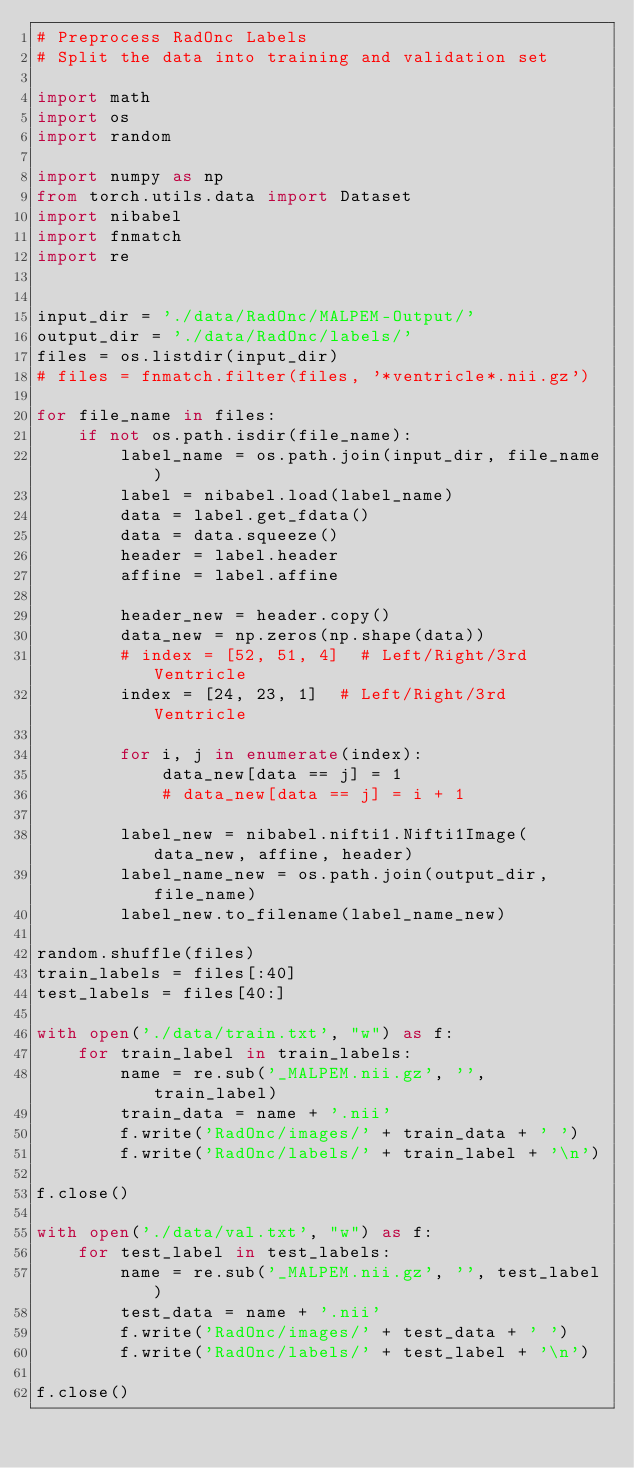<code> <loc_0><loc_0><loc_500><loc_500><_Python_># Preprocess RadOnc Labels
# Split the data into training and validation set

import math
import os
import random

import numpy as np
from torch.utils.data import Dataset
import nibabel
import fnmatch
import re


input_dir = './data/RadOnc/MALPEM-Output/'
output_dir = './data/RadOnc/labels/'
files = os.listdir(input_dir)
# files = fnmatch.filter(files, '*ventricle*.nii.gz')

for file_name in files:
    if not os.path.isdir(file_name):
        label_name = os.path.join(input_dir, file_name)
        label = nibabel.load(label_name)
        data = label.get_fdata()
        data = data.squeeze()
        header = label.header
        affine = label.affine

        header_new = header.copy()
        data_new = np.zeros(np.shape(data))
        # index = [52, 51, 4]  # Left/Right/3rd Ventricle
        index = [24, 23, 1]  # Left/Right/3rd Ventricle

        for i, j in enumerate(index):
            data_new[data == j] = 1
            # data_new[data == j] = i + 1

        label_new = nibabel.nifti1.Nifti1Image(data_new, affine, header)
        label_name_new = os.path.join(output_dir, file_name)
        label_new.to_filename(label_name_new)

random.shuffle(files)
train_labels = files[:40]
test_labels = files[40:]

with open('./data/train.txt', "w") as f:
    for train_label in train_labels:
        name = re.sub('_MALPEM.nii.gz', '', train_label)
        train_data = name + '.nii'
        f.write('RadOnc/images/' + train_data + ' ')
        f.write('RadOnc/labels/' + train_label + '\n')

f.close()

with open('./data/val.txt', "w") as f:
    for test_label in test_labels:
        name = re.sub('_MALPEM.nii.gz', '', test_label)
        test_data = name + '.nii'
        f.write('RadOnc/images/' + test_data + ' ')
        f.write('RadOnc/labels/' + test_label + '\n')

f.close()</code> 